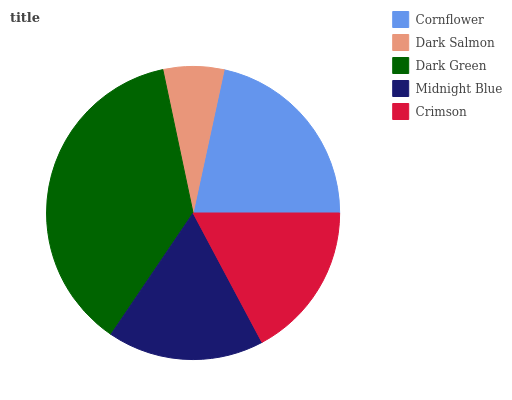Is Dark Salmon the minimum?
Answer yes or no. Yes. Is Dark Green the maximum?
Answer yes or no. Yes. Is Dark Green the minimum?
Answer yes or no. No. Is Dark Salmon the maximum?
Answer yes or no. No. Is Dark Green greater than Dark Salmon?
Answer yes or no. Yes. Is Dark Salmon less than Dark Green?
Answer yes or no. Yes. Is Dark Salmon greater than Dark Green?
Answer yes or no. No. Is Dark Green less than Dark Salmon?
Answer yes or no. No. Is Midnight Blue the high median?
Answer yes or no. Yes. Is Midnight Blue the low median?
Answer yes or no. Yes. Is Dark Green the high median?
Answer yes or no. No. Is Crimson the low median?
Answer yes or no. No. 